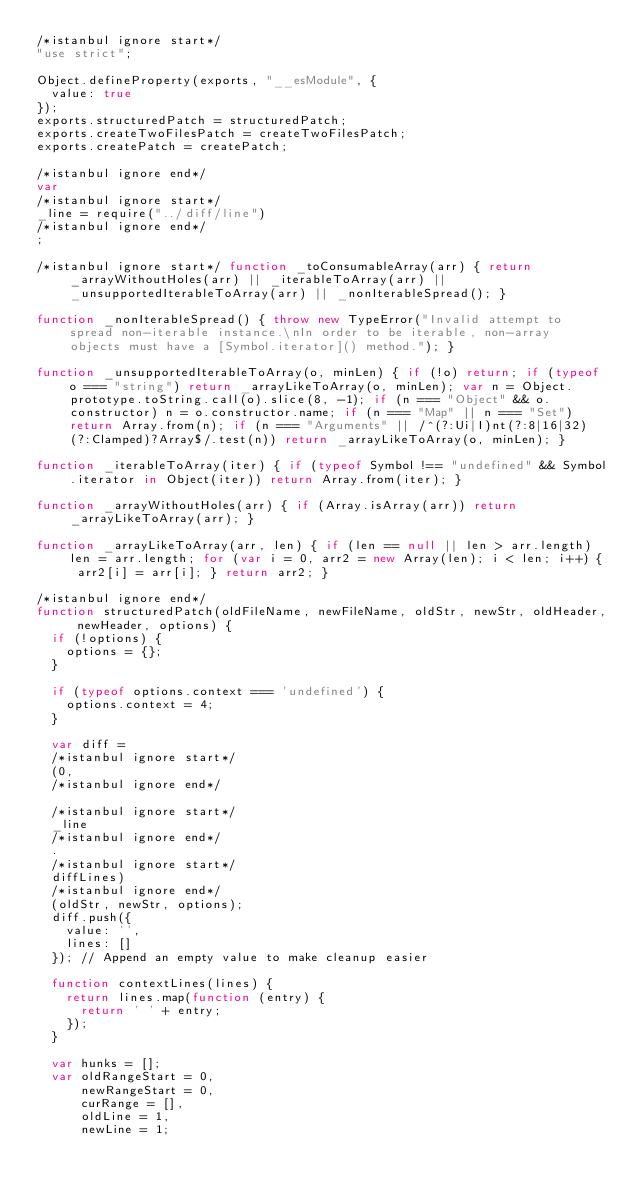Convert code to text. <code><loc_0><loc_0><loc_500><loc_500><_JavaScript_>/*istanbul ignore start*/
"use strict";

Object.defineProperty(exports, "__esModule", {
  value: true
});
exports.structuredPatch = structuredPatch;
exports.createTwoFilesPatch = createTwoFilesPatch;
exports.createPatch = createPatch;

/*istanbul ignore end*/
var
/*istanbul ignore start*/
_line = require("../diff/line")
/*istanbul ignore end*/
;

/*istanbul ignore start*/ function _toConsumableArray(arr) { return _arrayWithoutHoles(arr) || _iterableToArray(arr) || _unsupportedIterableToArray(arr) || _nonIterableSpread(); }

function _nonIterableSpread() { throw new TypeError("Invalid attempt to spread non-iterable instance.\nIn order to be iterable, non-array objects must have a [Symbol.iterator]() method."); }

function _unsupportedIterableToArray(o, minLen) { if (!o) return; if (typeof o === "string") return _arrayLikeToArray(o, minLen); var n = Object.prototype.toString.call(o).slice(8, -1); if (n === "Object" && o.constructor) n = o.constructor.name; if (n === "Map" || n === "Set") return Array.from(n); if (n === "Arguments" || /^(?:Ui|I)nt(?:8|16|32)(?:Clamped)?Array$/.test(n)) return _arrayLikeToArray(o, minLen); }

function _iterableToArray(iter) { if (typeof Symbol !== "undefined" && Symbol.iterator in Object(iter)) return Array.from(iter); }

function _arrayWithoutHoles(arr) { if (Array.isArray(arr)) return _arrayLikeToArray(arr); }

function _arrayLikeToArray(arr, len) { if (len == null || len > arr.length) len = arr.length; for (var i = 0, arr2 = new Array(len); i < len; i++) { arr2[i] = arr[i]; } return arr2; }

/*istanbul ignore end*/
function structuredPatch(oldFileName, newFileName, oldStr, newStr, oldHeader, newHeader, options) {
  if (!options) {
    options = {};
  }

  if (typeof options.context === 'undefined') {
    options.context = 4;
  }

  var diff =
  /*istanbul ignore start*/
  (0,
  /*istanbul ignore end*/

  /*istanbul ignore start*/
  _line
  /*istanbul ignore end*/
  .
  /*istanbul ignore start*/
  diffLines)
  /*istanbul ignore end*/
  (oldStr, newStr, options);
  diff.push({
    value: '',
    lines: []
  }); // Append an empty value to make cleanup easier

  function contextLines(lines) {
    return lines.map(function (entry) {
      return ' ' + entry;
    });
  }

  var hunks = [];
  var oldRangeStart = 0,
      newRangeStart = 0,
      curRange = [],
      oldLine = 1,
      newLine = 1;
</code> 